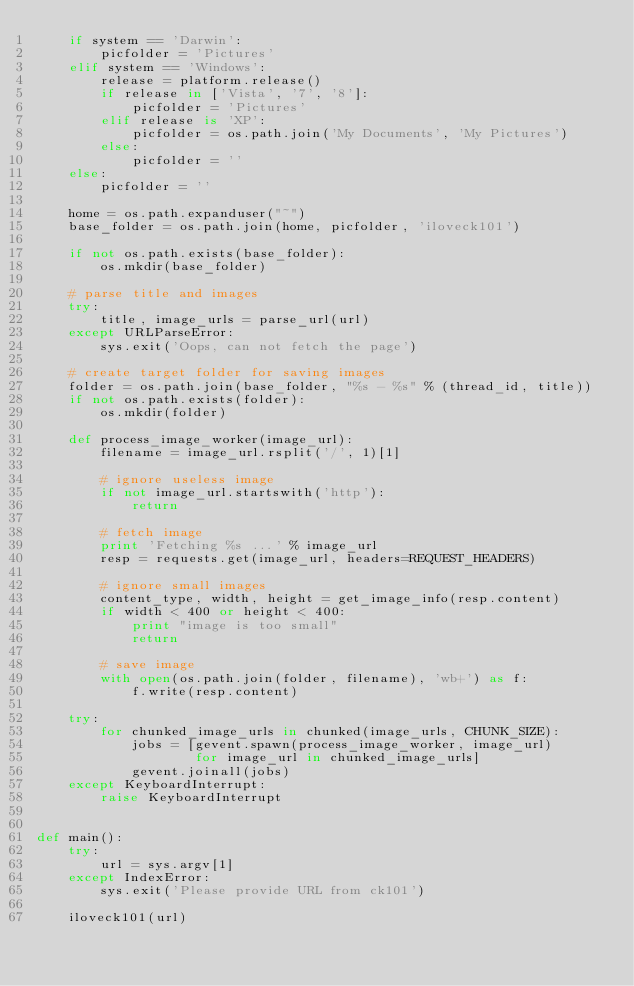<code> <loc_0><loc_0><loc_500><loc_500><_Python_>    if system == 'Darwin':
        picfolder = 'Pictures'
    elif system == 'Windows':
        release = platform.release()
        if release in ['Vista', '7', '8']:
            picfolder = 'Pictures'
        elif release is 'XP':
            picfolder = os.path.join('My Documents', 'My Pictures')
        else:
            picfolder = ''
    else:
        picfolder = ''

    home = os.path.expanduser("~")
    base_folder = os.path.join(home, picfolder, 'iloveck101')

    if not os.path.exists(base_folder):
        os.mkdir(base_folder)

    # parse title and images
    try:
        title, image_urls = parse_url(url)
    except URLParseError:
        sys.exit('Oops, can not fetch the page')

    # create target folder for saving images
    folder = os.path.join(base_folder, "%s - %s" % (thread_id, title))
    if not os.path.exists(folder):
        os.mkdir(folder)

    def process_image_worker(image_url):
        filename = image_url.rsplit('/', 1)[1]

        # ignore useless image
        if not image_url.startswith('http'):
            return

        # fetch image
        print 'Fetching %s ...' % image_url
        resp = requests.get(image_url, headers=REQUEST_HEADERS)

        # ignore small images
        content_type, width, height = get_image_info(resp.content)
        if width < 400 or height < 400:
            print "image is too small"
            return

        # save image
        with open(os.path.join(folder, filename), 'wb+') as f:
            f.write(resp.content)

    try:
        for chunked_image_urls in chunked(image_urls, CHUNK_SIZE):
            jobs = [gevent.spawn(process_image_worker, image_url)
                    for image_url in chunked_image_urls]
            gevent.joinall(jobs)
    except KeyboardInterrupt:
        raise KeyboardInterrupt


def main():
    try:
        url = sys.argv[1]
    except IndexError:
        sys.exit('Please provide URL from ck101')

    iloveck101(url)
</code> 